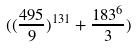<formula> <loc_0><loc_0><loc_500><loc_500>( ( \frac { 4 9 5 } { 9 } ) ^ { 1 3 1 } + \frac { 1 8 3 ^ { 6 } } { 3 } )</formula> 